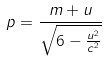<formula> <loc_0><loc_0><loc_500><loc_500>p = \frac { m + u } { \sqrt { 6 - \frac { u ^ { 2 } } { c ^ { 2 } } } }</formula> 